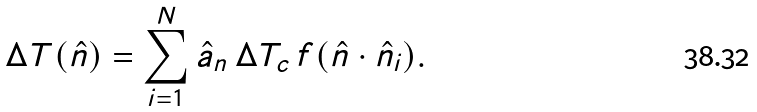Convert formula to latex. <formula><loc_0><loc_0><loc_500><loc_500>\Delta T ( \hat { n } ) = \sum ^ { N } _ { i = 1 } \hat { a } _ { n } \, \Delta T _ { c } \, f ( \hat { n } \cdot \hat { n } _ { i } ) .</formula> 